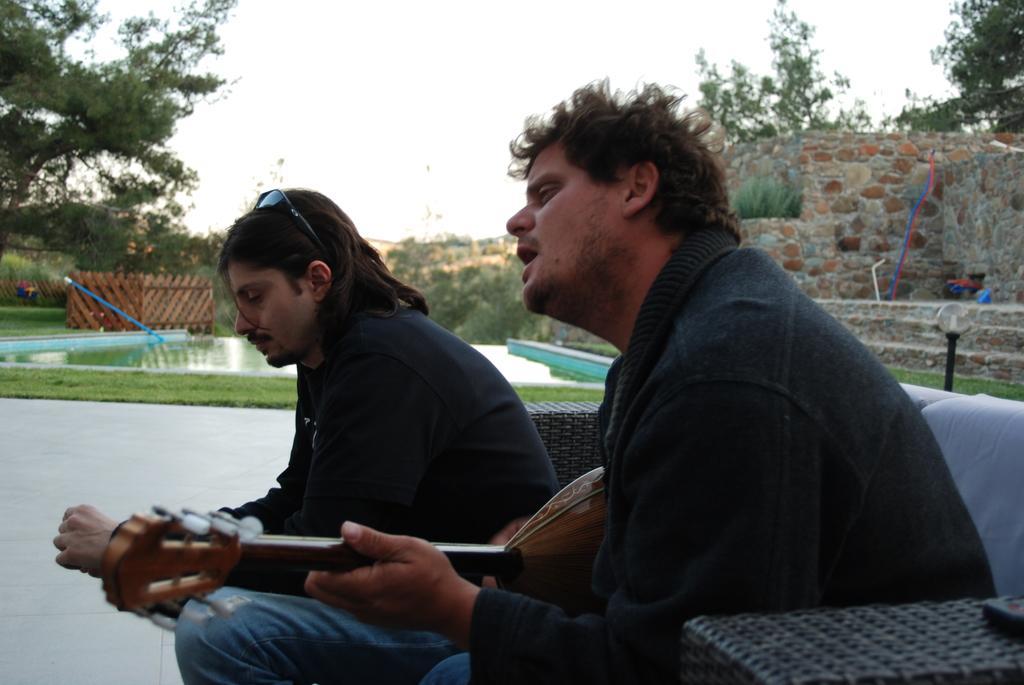Could you give a brief overview of what you see in this image? In this image there are two persons at the foreground of the image there is a person playing guitar and at the background of the image there is a person sitting and at the background of the image there are some trees,wall and a swimming pool. 